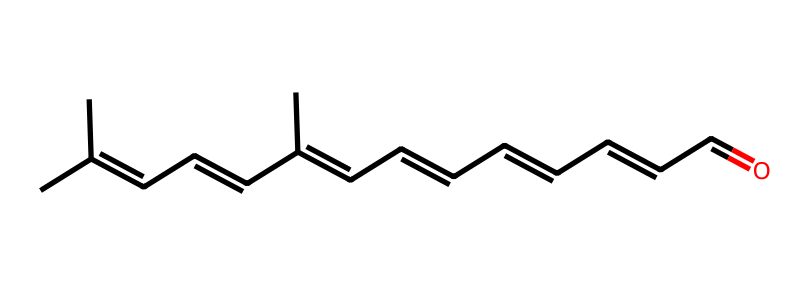What is the molecular formula of retinal? By counting the carbon (C), hydrogen (H), and oxygen (O) atoms in the SMILES representation, we can deduce that there are 20 carbon atoms, 28 hydrogen atoms, and 1 oxygen atom, leading to the molecular formula C20H28O.
Answer: C20H28O How many double bonds are present in retinal? In the structure drawn from the SMILES notation, each occurrence of "=" indicates a double bond. By carefully counting, we find there are 5 double bonds in total within the retinal molecule.
Answer: 5 What type of isomerism is exhibited in retinal? The SMILES representation indicates the presence of different geometric arrangements around the double bonds, which refers to cis-trans isomerism. This is a common feature when multiple double bonds are present in a long carbon chain, suggesting this type of isomerism specifically.
Answer: cis-trans What effect does the cis arrangement in retinal have on its function? The cis configuration around double bonds in retinal is crucial as it allows the molecule to effectively fit into the binding sites of proteins, such as rhodopsin in the retina, contributing to its biological function in vision.
Answer: effective fitting Which structural feature of retinal is responsible for its light absorption? The alternating double bonds (conjugated system) within the retinal structure allow for the absorption of light within the visible spectrum. This specific arrangement makes it particularly effective in photoreception for vision.
Answer: conjugated system 